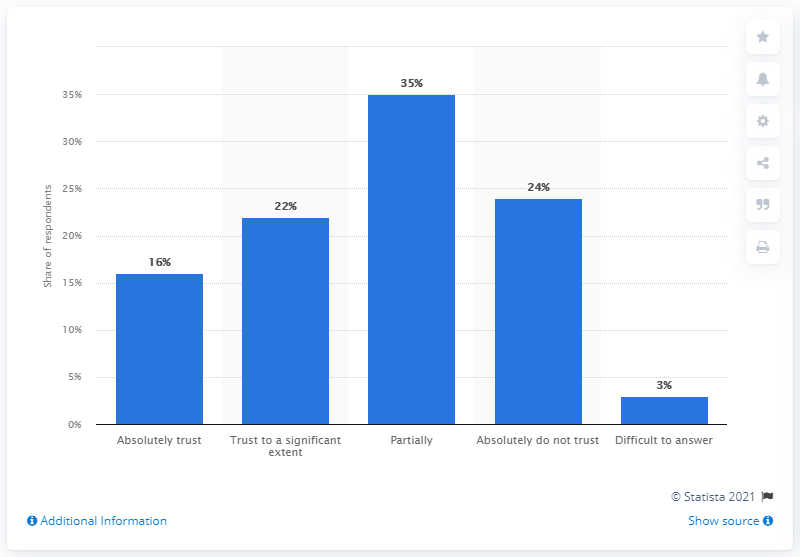Give some essential details in this illustration. According to data from mass media, approximately 16% of Russians expressed full trust in the official COVID-19 statistics provided by the government in the first half of 2020. 